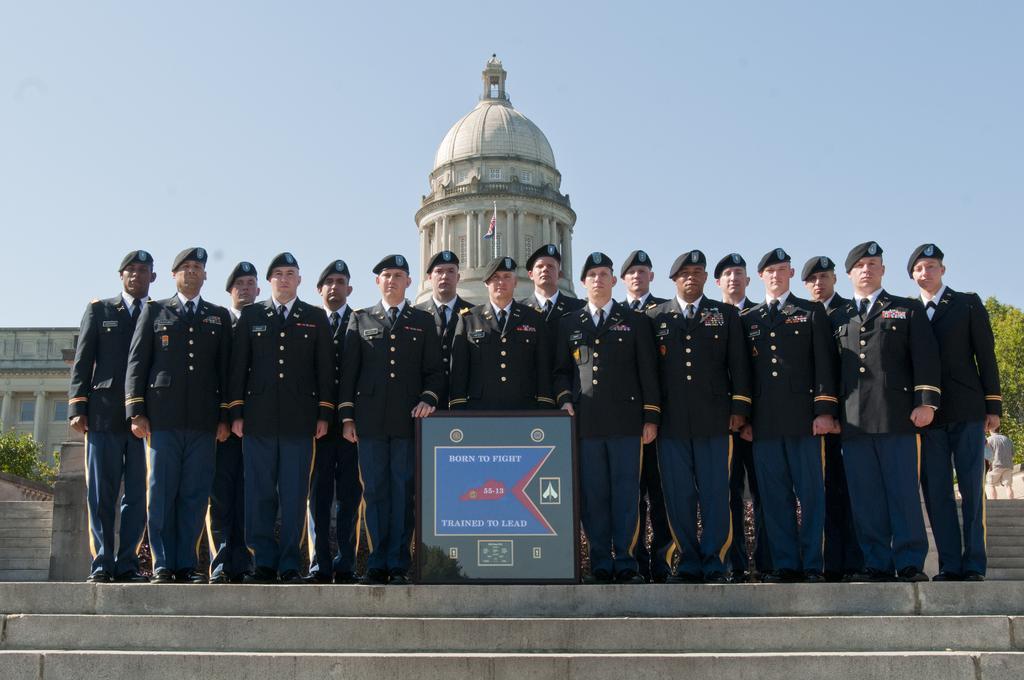In one or two sentences, can you explain what this image depicts? This picture describes about group of people, in the middle of the image we can see few people wore caps, in front of them we can find a shield, in the background we can see few buildings, trees and a flag. 